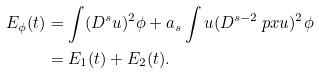<formula> <loc_0><loc_0><loc_500><loc_500>E _ { \phi } ( t ) & = \int ( D ^ { s } u ) ^ { 2 } \phi + a _ { s } \int u ( D ^ { s - 2 } \ p x u ) ^ { 2 } \phi \\ & = E _ { 1 } ( t ) + E _ { 2 } ( t ) .</formula> 